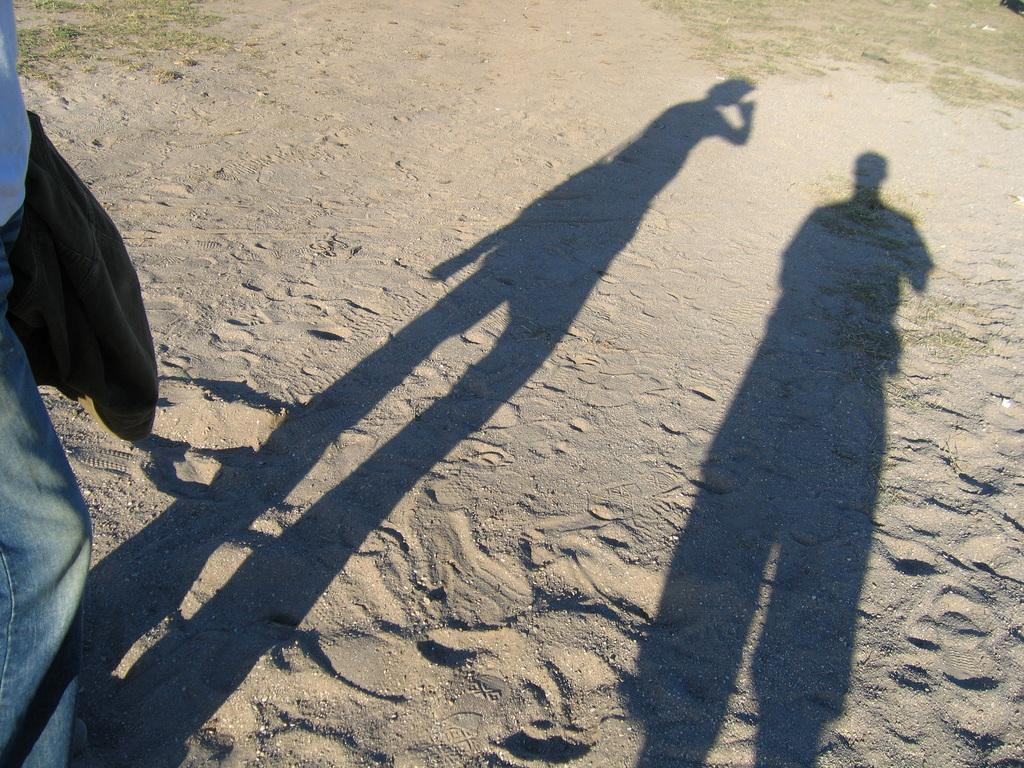What is the main subject in the image? There is a person standing in the image. What else can be observed in the image besides the person? Shadows are visible in the image, and sand is present on the ground. What type of soup is being served in the image? There is no soup present in the image; it features a person standing on sand with visible shadows. 